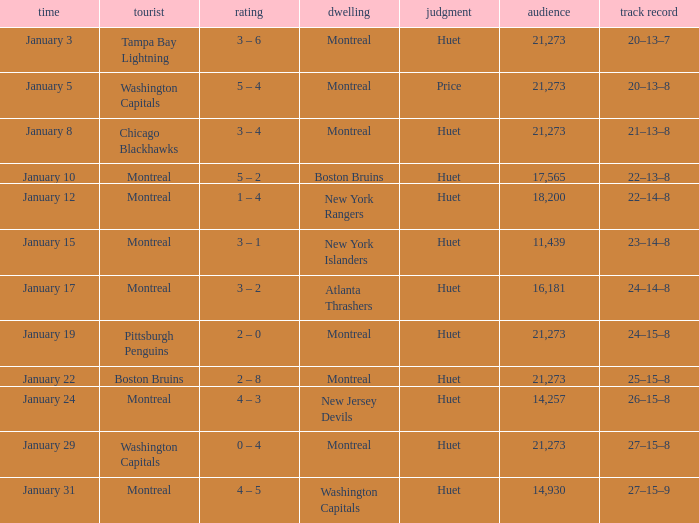What was the score of the game when the Boston Bruins were the visiting team? 2 – 8. 